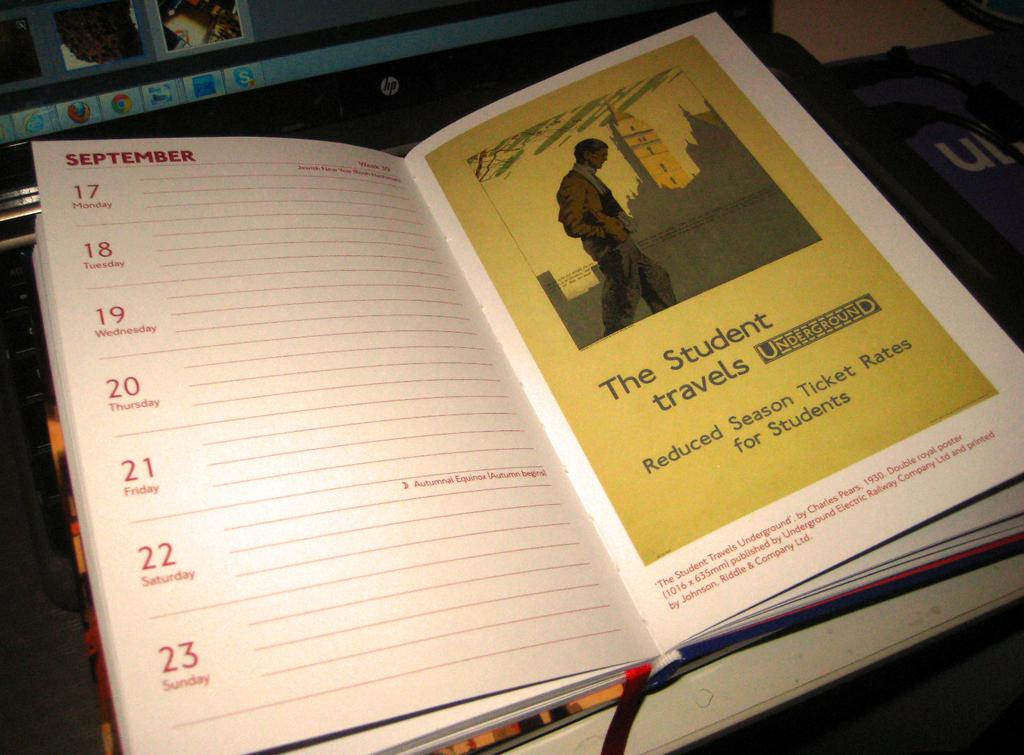<image>
Write a terse but informative summary of the picture. A datebook has a page about student travels and reduced ticket rates for students. 